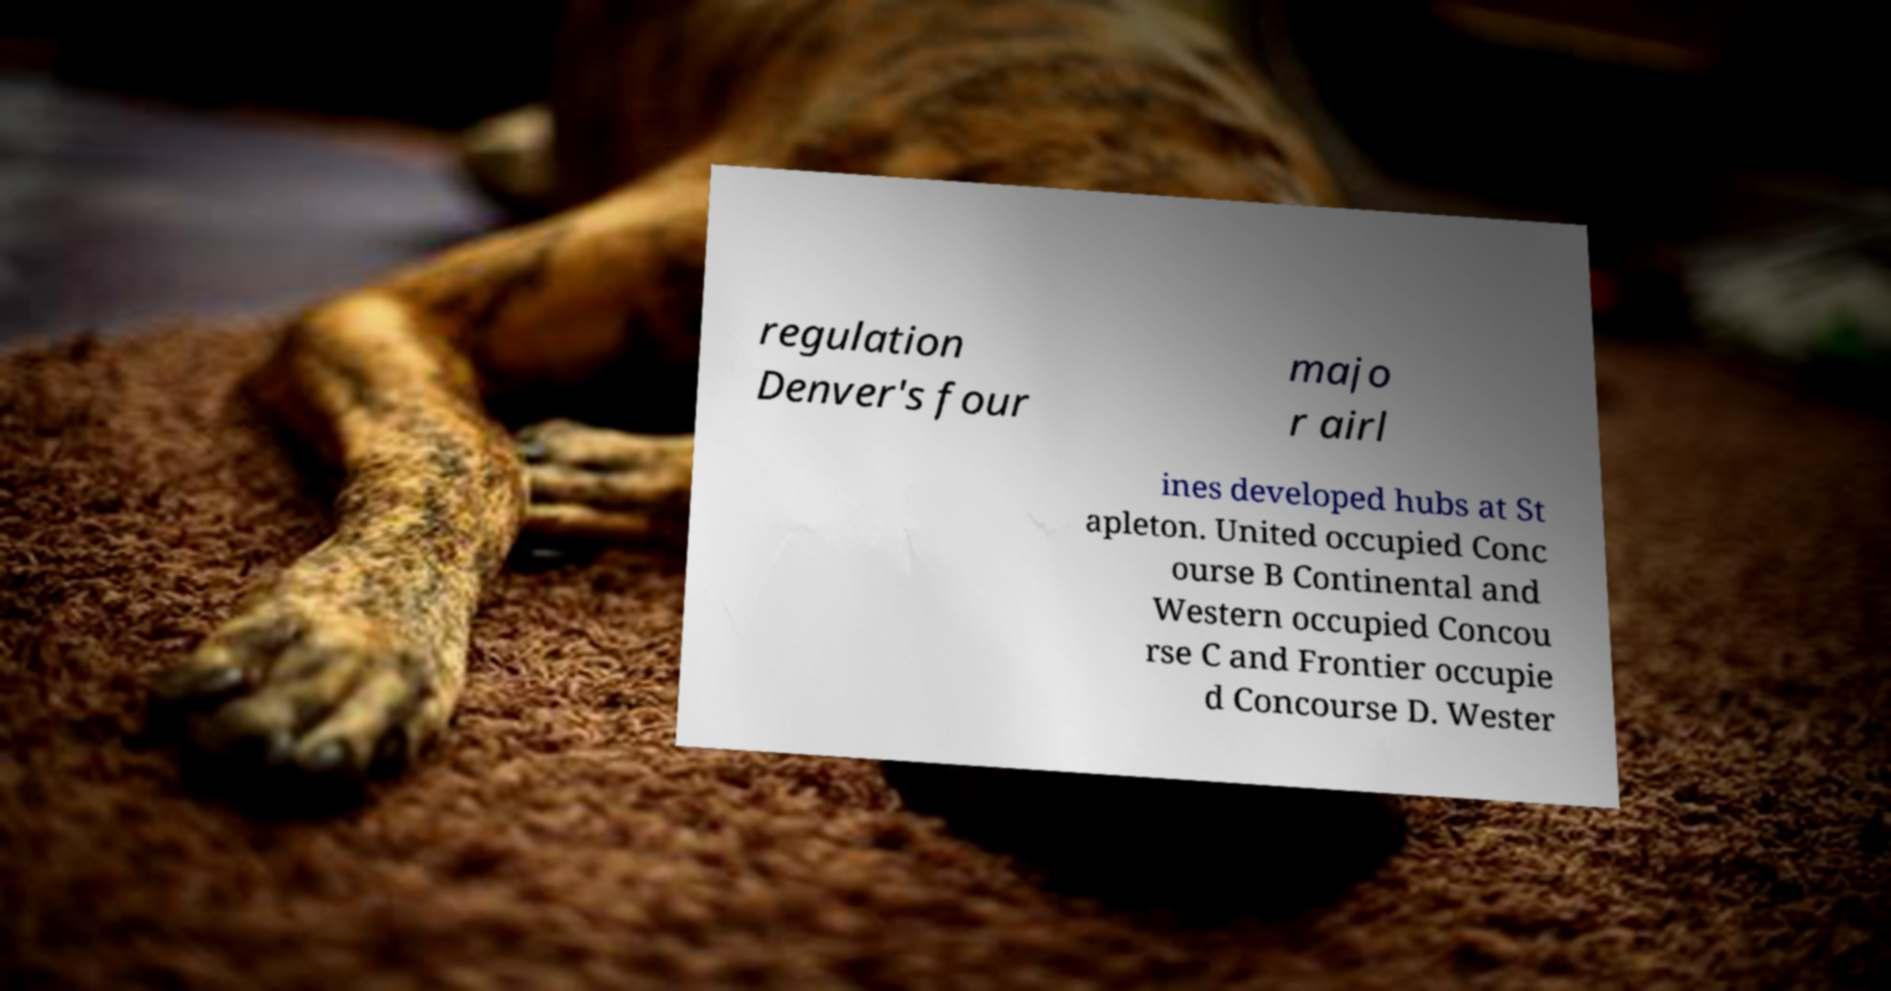Could you extract and type out the text from this image? regulation Denver's four majo r airl ines developed hubs at St apleton. United occupied Conc ourse B Continental and Western occupied Concou rse C and Frontier occupie d Concourse D. Wester 